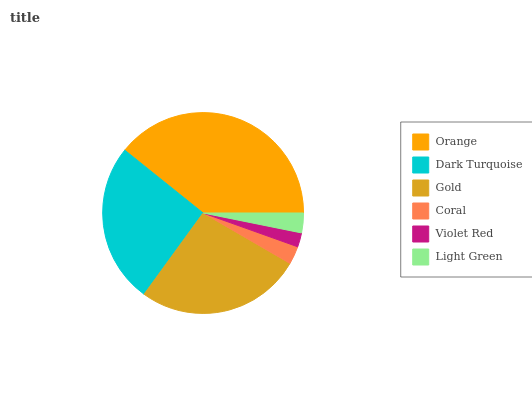Is Violet Red the minimum?
Answer yes or no. Yes. Is Orange the maximum?
Answer yes or no. Yes. Is Dark Turquoise the minimum?
Answer yes or no. No. Is Dark Turquoise the maximum?
Answer yes or no. No. Is Orange greater than Dark Turquoise?
Answer yes or no. Yes. Is Dark Turquoise less than Orange?
Answer yes or no. Yes. Is Dark Turquoise greater than Orange?
Answer yes or no. No. Is Orange less than Dark Turquoise?
Answer yes or no. No. Is Dark Turquoise the high median?
Answer yes or no. Yes. Is Light Green the low median?
Answer yes or no. Yes. Is Coral the high median?
Answer yes or no. No. Is Violet Red the low median?
Answer yes or no. No. 